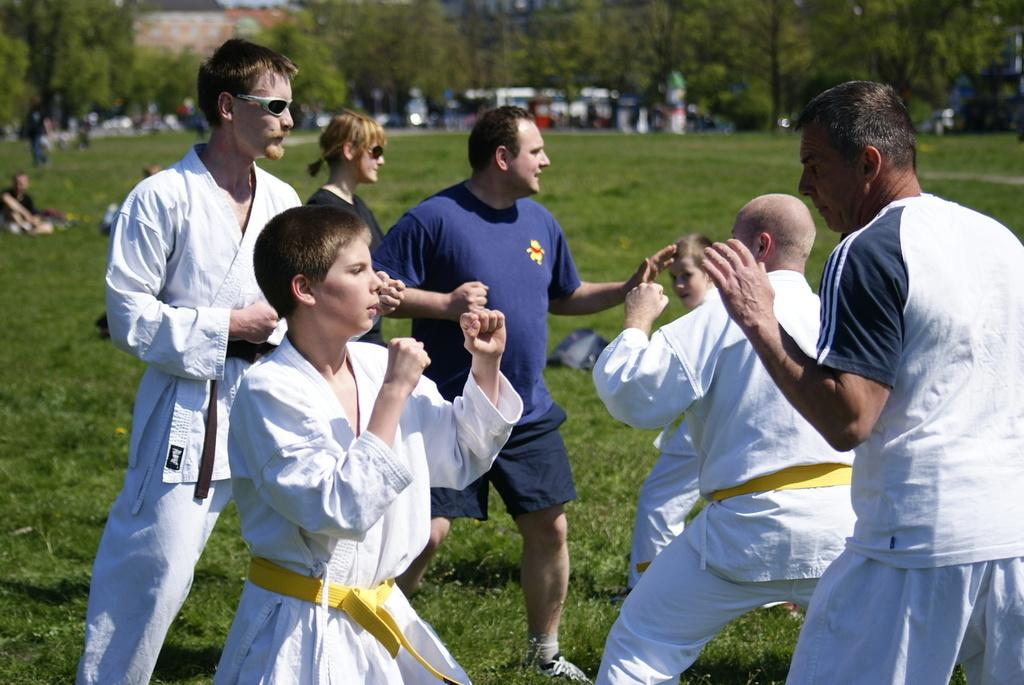What type of clothing are the people in the image wearing? The people in the image are wearing karate dress. How are the people positioned in the image? Some of the people are standing in the front, while others are sitting in the back. What can be seen in the background of the image? There are trees visible in the background of the image. What type of dog can be seen playing with scissors in the image? There is no dog or scissors present in the image; it features people in karate dress. 